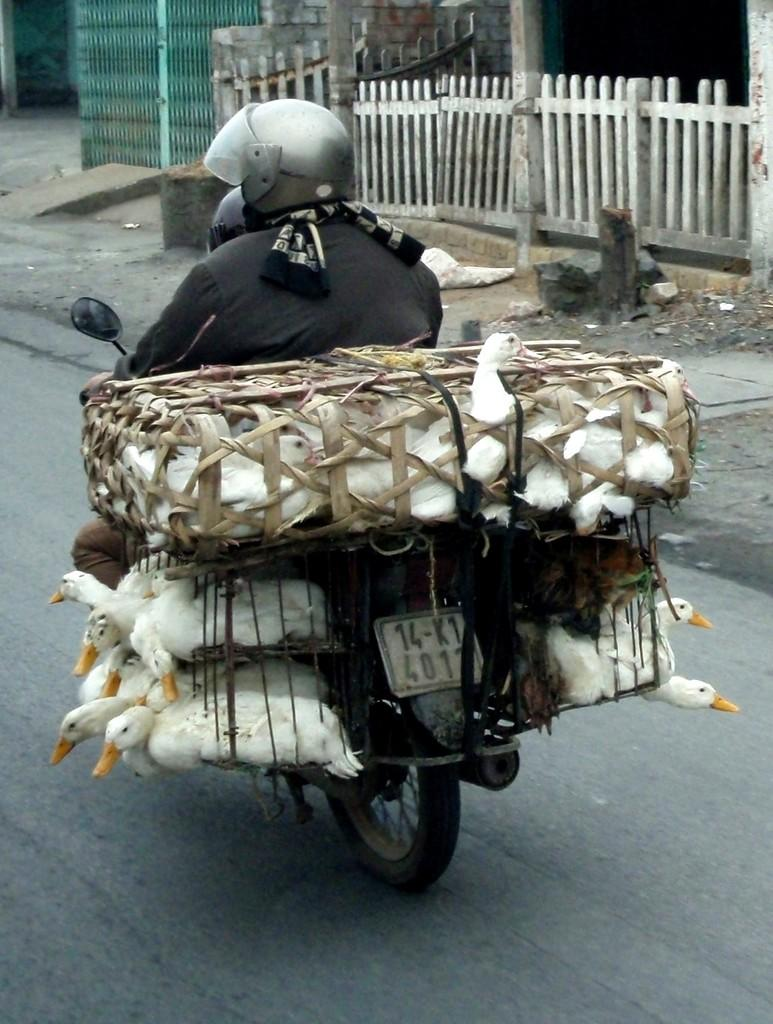What is the person in the image doing? There is a person riding a bike in the image. What is in the basket on the bike? There are ducks in a basket on the bike. What architectural features can be seen in the image? There are gates and a fence visible in the image. What type of shoes is the person wearing while riding the bike? There is no information about the person's shoes in the image, so it cannot be determined. 